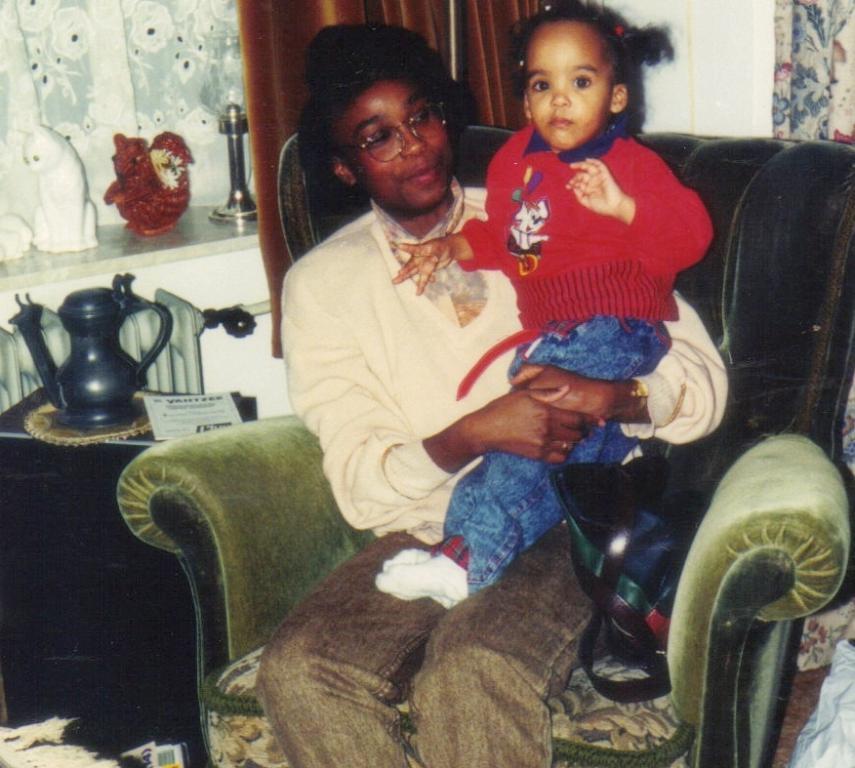Please provide a concise description of this image. In this image I can see a person and the child sitting on the chair. On the table there is ajar and a paper. 